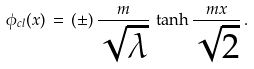<formula> <loc_0><loc_0><loc_500><loc_500>\phi _ { c l } ( x ) \, = \, ( \pm ) \, \frac { m } { \sqrt { \lambda } } \, \tanh \frac { m x } { \sqrt { 2 } } \, .</formula> 